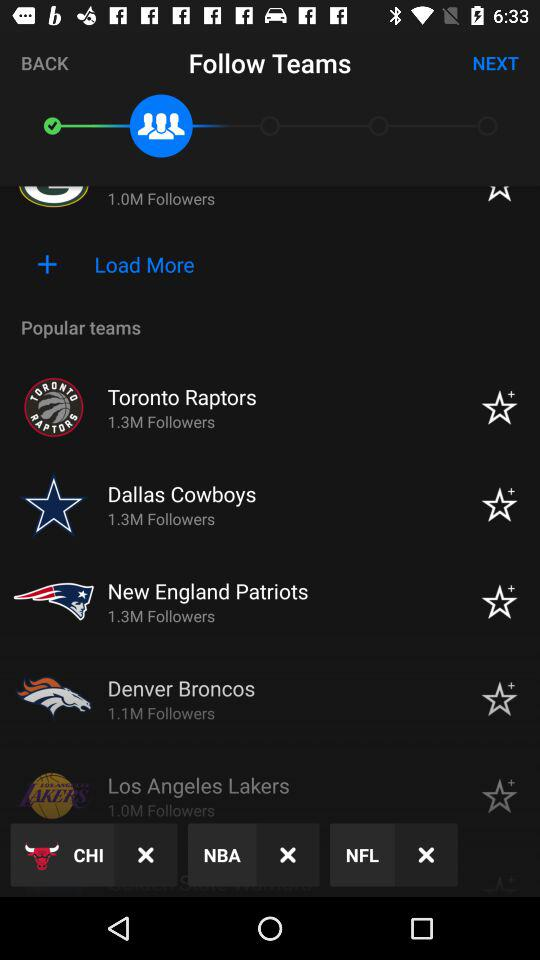What is the follower count of the Dallas Cowboys? The count of followers is 1.3 million. 